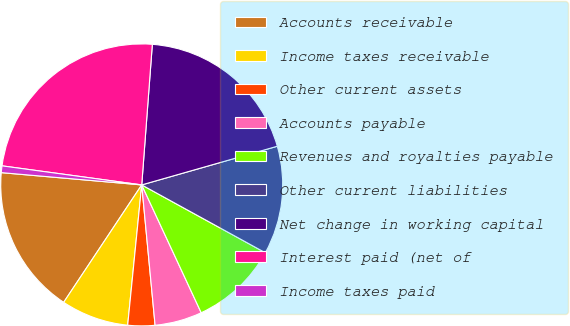Convert chart to OTSL. <chart><loc_0><loc_0><loc_500><loc_500><pie_chart><fcel>Accounts receivable<fcel>Income taxes receivable<fcel>Other current assets<fcel>Accounts payable<fcel>Revenues and royalties payable<fcel>Other current liabilities<fcel>Net change in working capital<fcel>Interest paid (net of<fcel>Income taxes paid<nl><fcel>17.05%<fcel>7.75%<fcel>3.1%<fcel>5.42%<fcel>10.08%<fcel>12.41%<fcel>19.38%<fcel>24.04%<fcel>0.77%<nl></chart> 